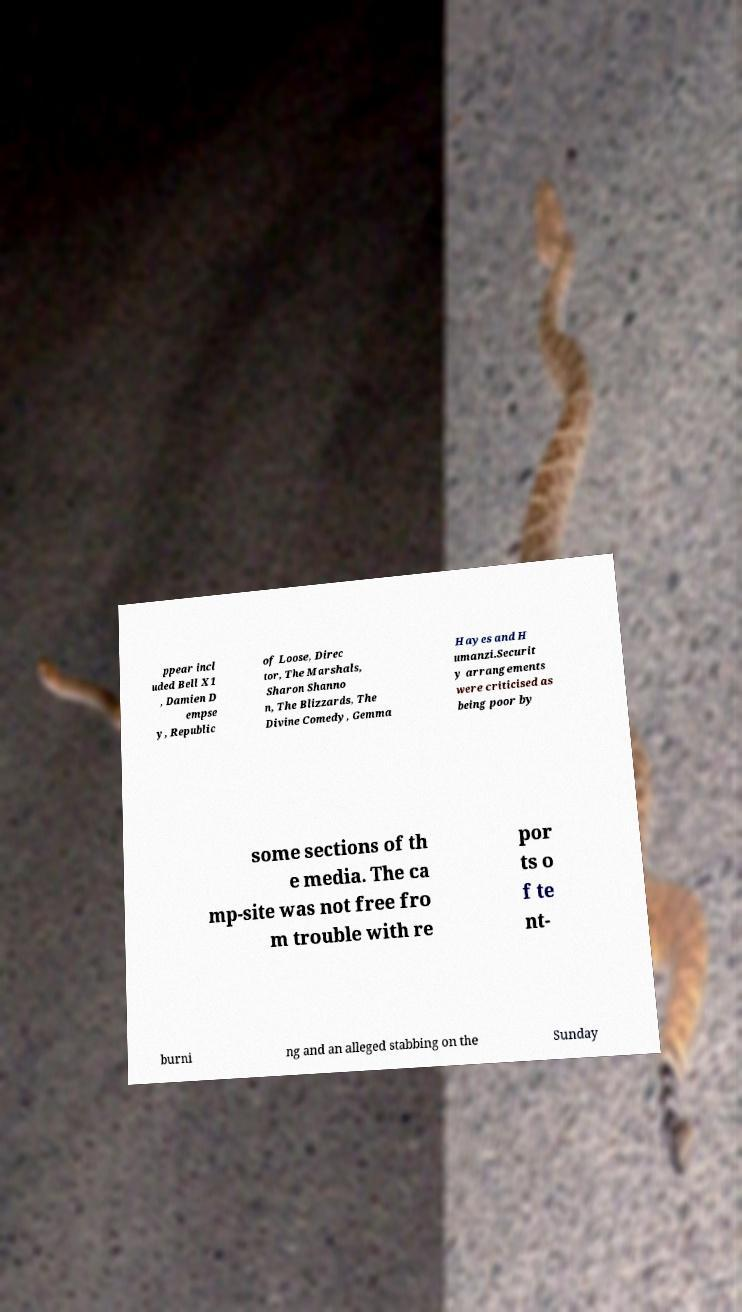I need the written content from this picture converted into text. Can you do that? ppear incl uded Bell X1 , Damien D empse y, Republic of Loose, Direc tor, The Marshals, Sharon Shanno n, The Blizzards, The Divine Comedy, Gemma Hayes and H umanzi.Securit y arrangements were criticised as being poor by some sections of th e media. The ca mp-site was not free fro m trouble with re por ts o f te nt- burni ng and an alleged stabbing on the Sunday 